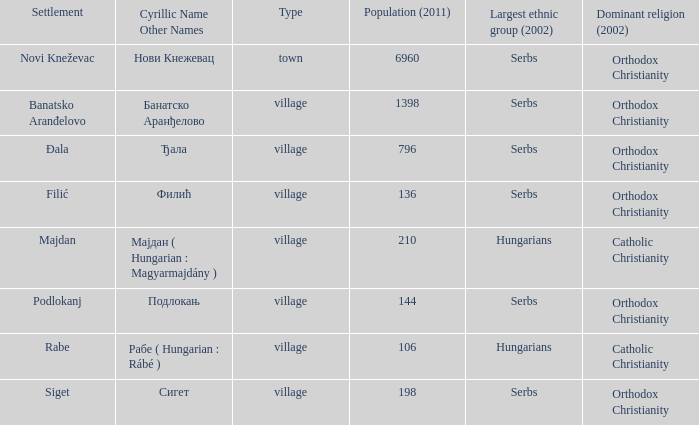In the settlement with the cyrillic designation банатско аранђелово, which ethnic group is the most populous? Serbs. 